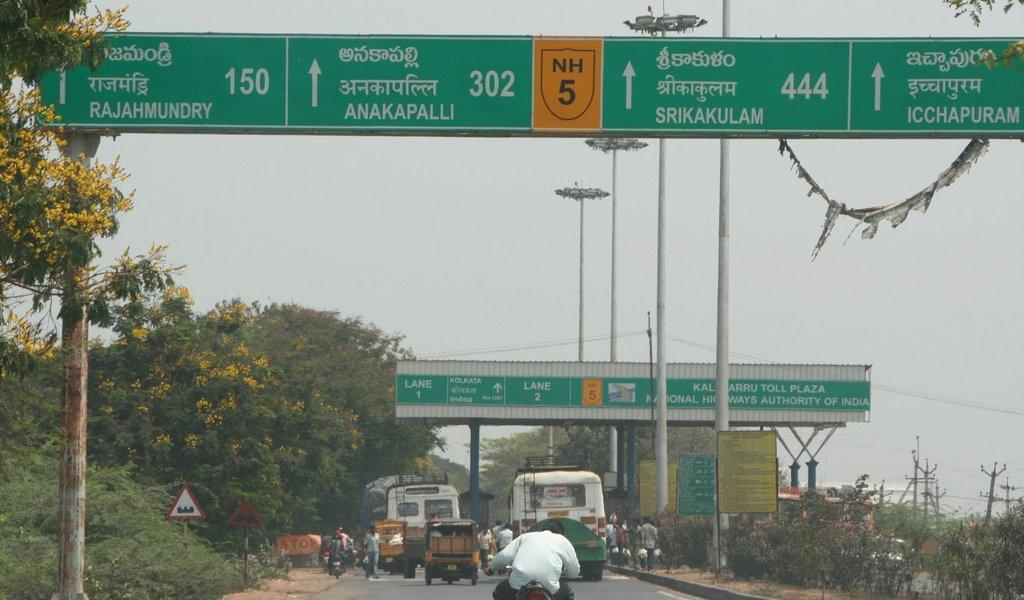<image>
Create a compact narrative representing the image presented. Multiple vehicles on a highway approach a toll plaza in India. 